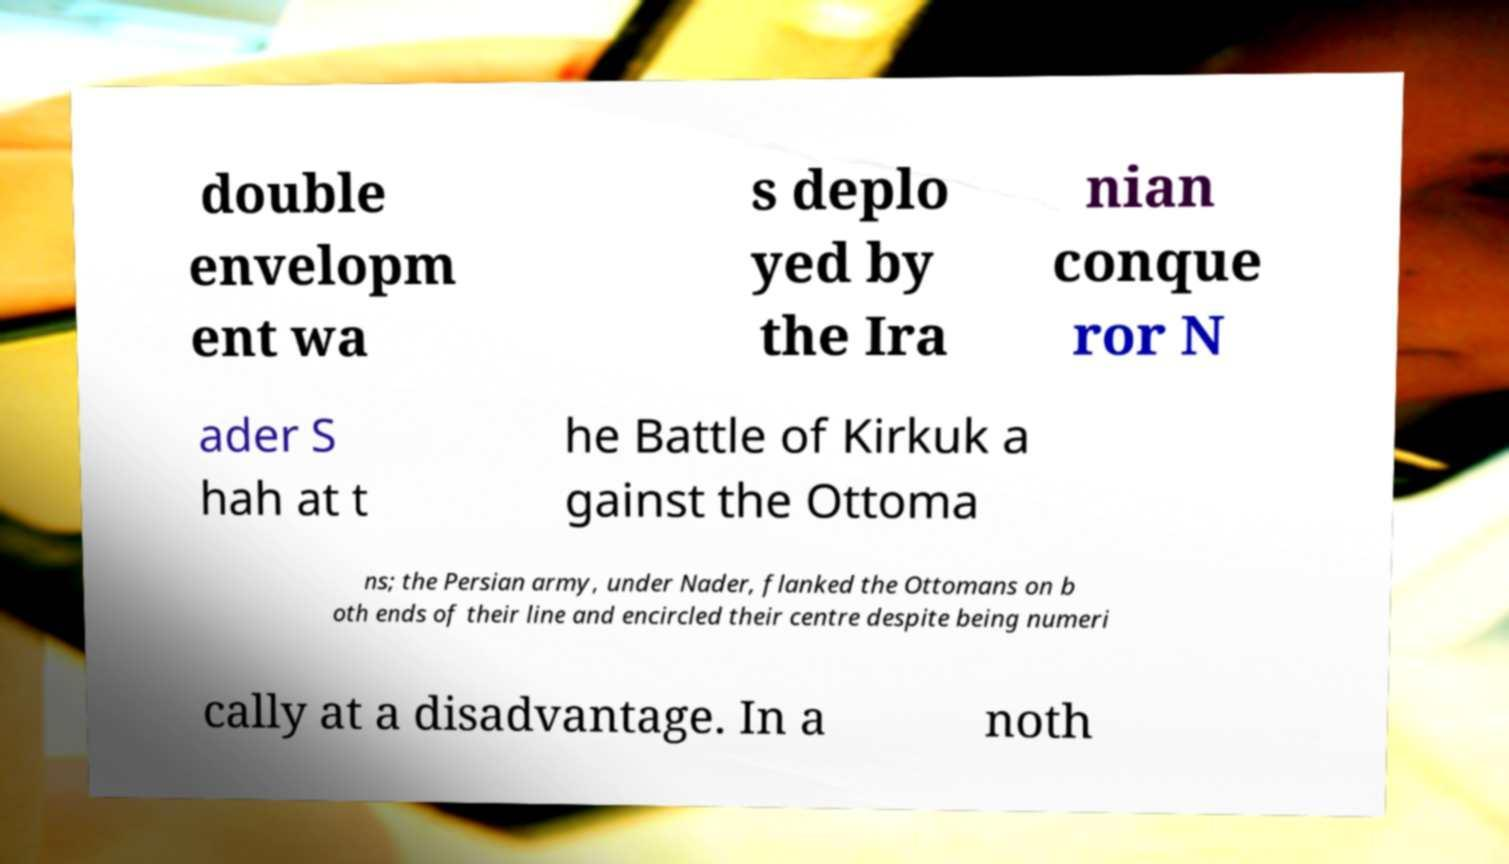There's text embedded in this image that I need extracted. Can you transcribe it verbatim? double envelopm ent wa s deplo yed by the Ira nian conque ror N ader S hah at t he Battle of Kirkuk a gainst the Ottoma ns; the Persian army, under Nader, flanked the Ottomans on b oth ends of their line and encircled their centre despite being numeri cally at a disadvantage. In a noth 